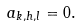Convert formula to latex. <formula><loc_0><loc_0><loc_500><loc_500>a _ { k , h , l } = 0 .</formula> 